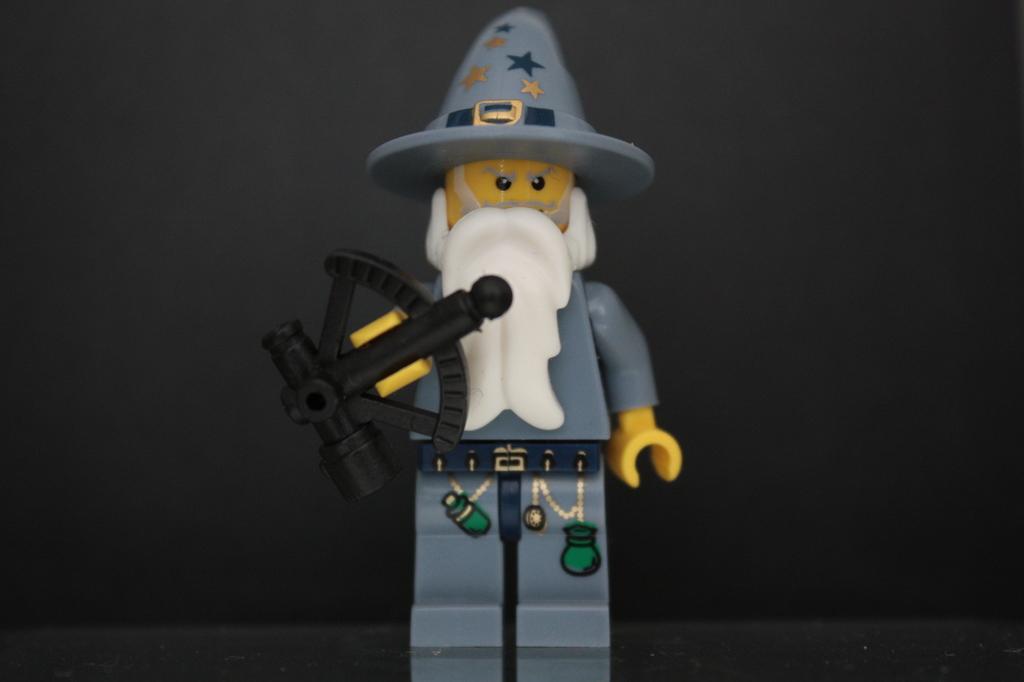In one or two sentences, can you explain what this image depicts? In this picture we can see a toy. 